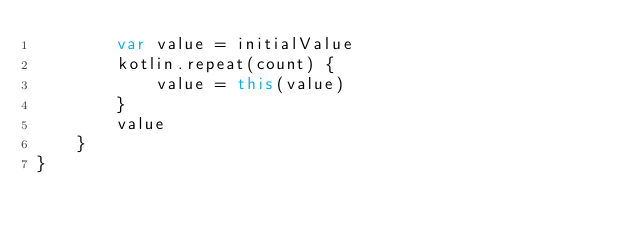Convert code to text. <code><loc_0><loc_0><loc_500><loc_500><_Kotlin_>        var value = initialValue
        kotlin.repeat(count) {
            value = this(value)
        }
        value
    }
}
</code> 